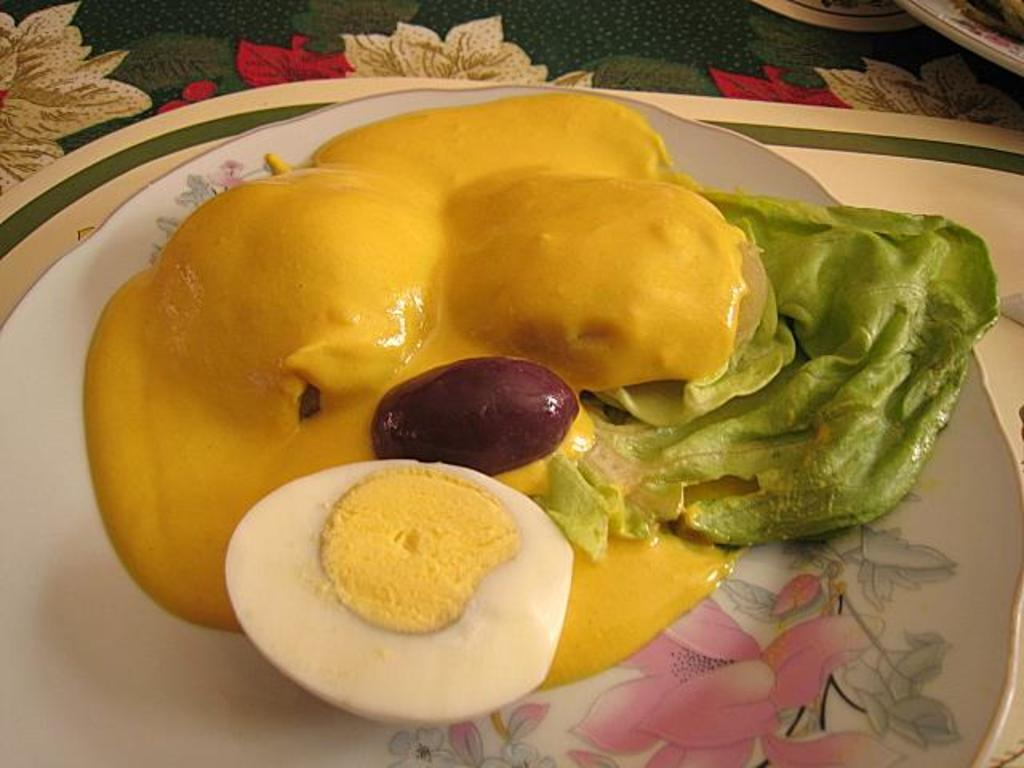What is present on the surface in the image? There is a plate in the image. What is the plate placed on? The plate is on a mat. What is in the plate? There is a food item in the plate, specifically an egg. How many men are touching the insect in the image? There are no men or insects present in the image. 